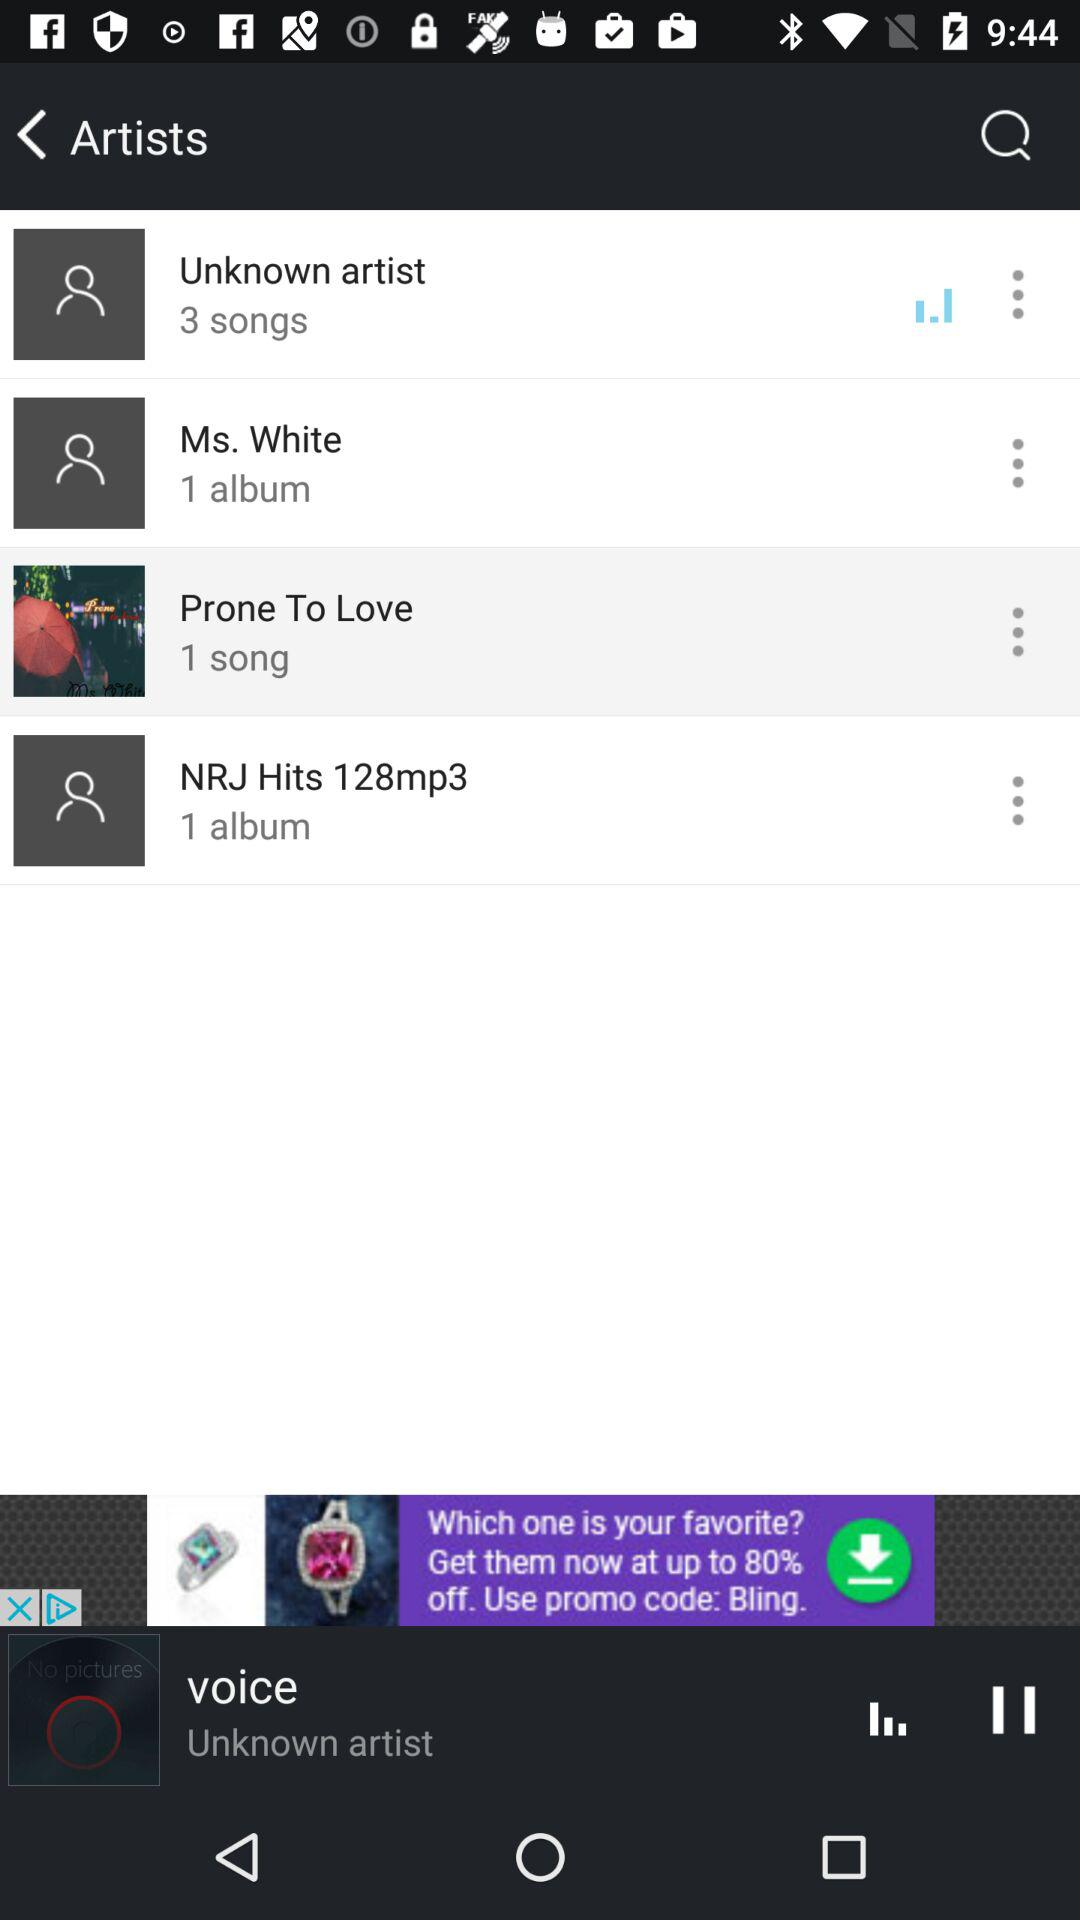What is the number of songs in "Prone To Love"? The number of songs is 1. 